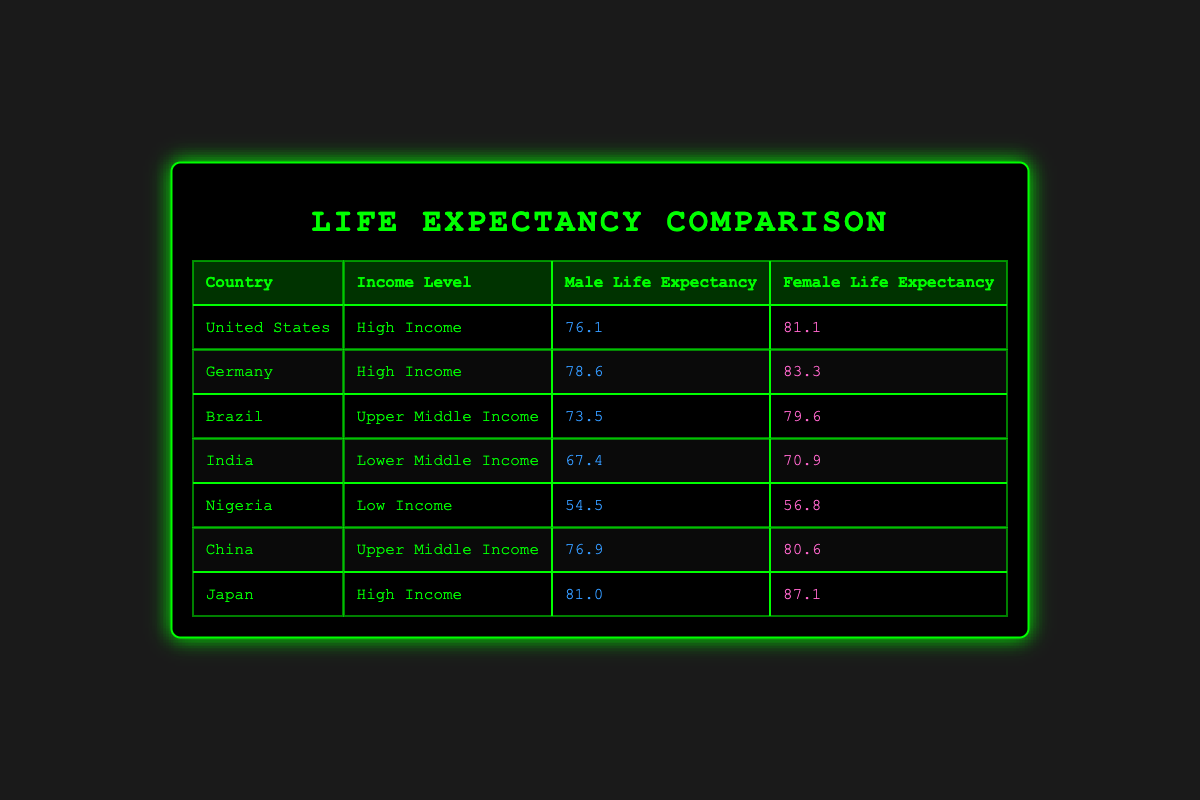What is the male life expectancy in Japan? The table directly shows the life expectancy for males in Japan as 81.0.
Answer: 81.0 Which country has the highest female life expectancy among high-income countries? In the table, Germany has a female life expectancy of 83.3, while the United States has 81.1 and Japan has 87.1. Therefore, Japan has the highest female life expectancy among high-income countries.
Answer: Japan What is the difference in life expectancy between males and females in Nigeria? In Nigeria, males have a life expectancy of 54.5 and females 56.8. The difference is calculated as 56.8 - 54.5 = 2.3.
Answer: 2.3 Is Brazil classified as a low-income country? The table categorizes Brazil as an upper middle-income country, which means it is not classified as low income.
Answer: No What is the average life expectancy for females in upper middle-income countries? The table shows that Brazil has a female life expectancy of 79.6 and China has 80.6. To find the average, we add these values (79.6 + 80.6 = 160.2) and divide by 2. The average female life expectancy in upper middle-income countries is 160.2 / 2 = 80.1.
Answer: 80.1 Which country has the lowest male life expectancy, and what is that value? By checking the table, Nigeria has the lowest male life expectancy at 54.5.
Answer: Nigeria, 54.5 How many countries listed have a higher female life expectancy than 80 years? Reviewing the data, Japan (87.1), Germany (83.3), and China (80.6) are the countries with female life expectancy above 80. Three countries meet this criterion.
Answer: 3 What is the life expectancy difference between males and females in high-income countries? For high-income countries, the male life expectancies are 76.1 (United States), 78.6 (Germany), and 81.0 (Japan). The female life expectancies are 81.1, 83.3, and 87.1, respectively. The differences for each are 5.0, 4.7, and 6.1. To find the average difference, we sum them up (5.0 + 4.7 + 6.1 = 15.8) and divide by 3, leading to an average difference of 15.8 / 3 = 5.27.
Answer: 5.27 What gender has a higher life expectancy in India? In the table, Female life expectancy in India is 70.9, which is higher than the male life expectancy of 67.4.
Answer: Female 